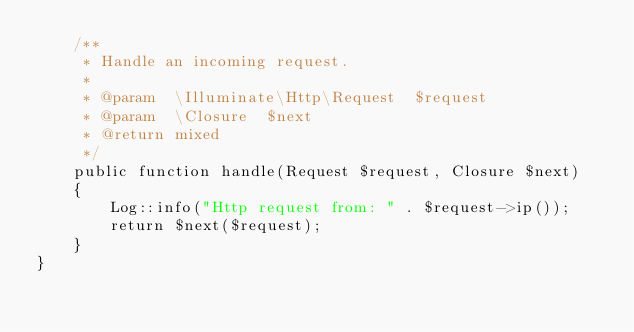Convert code to text. <code><loc_0><loc_0><loc_500><loc_500><_PHP_>    /**
     * Handle an incoming request.
     *
     * @param  \Illuminate\Http\Request  $request
     * @param  \Closure  $next
     * @return mixed
     */
    public function handle(Request $request, Closure $next)
    {
        Log::info("Http request from: " . $request->ip());
        return $next($request);
    }
}
</code> 